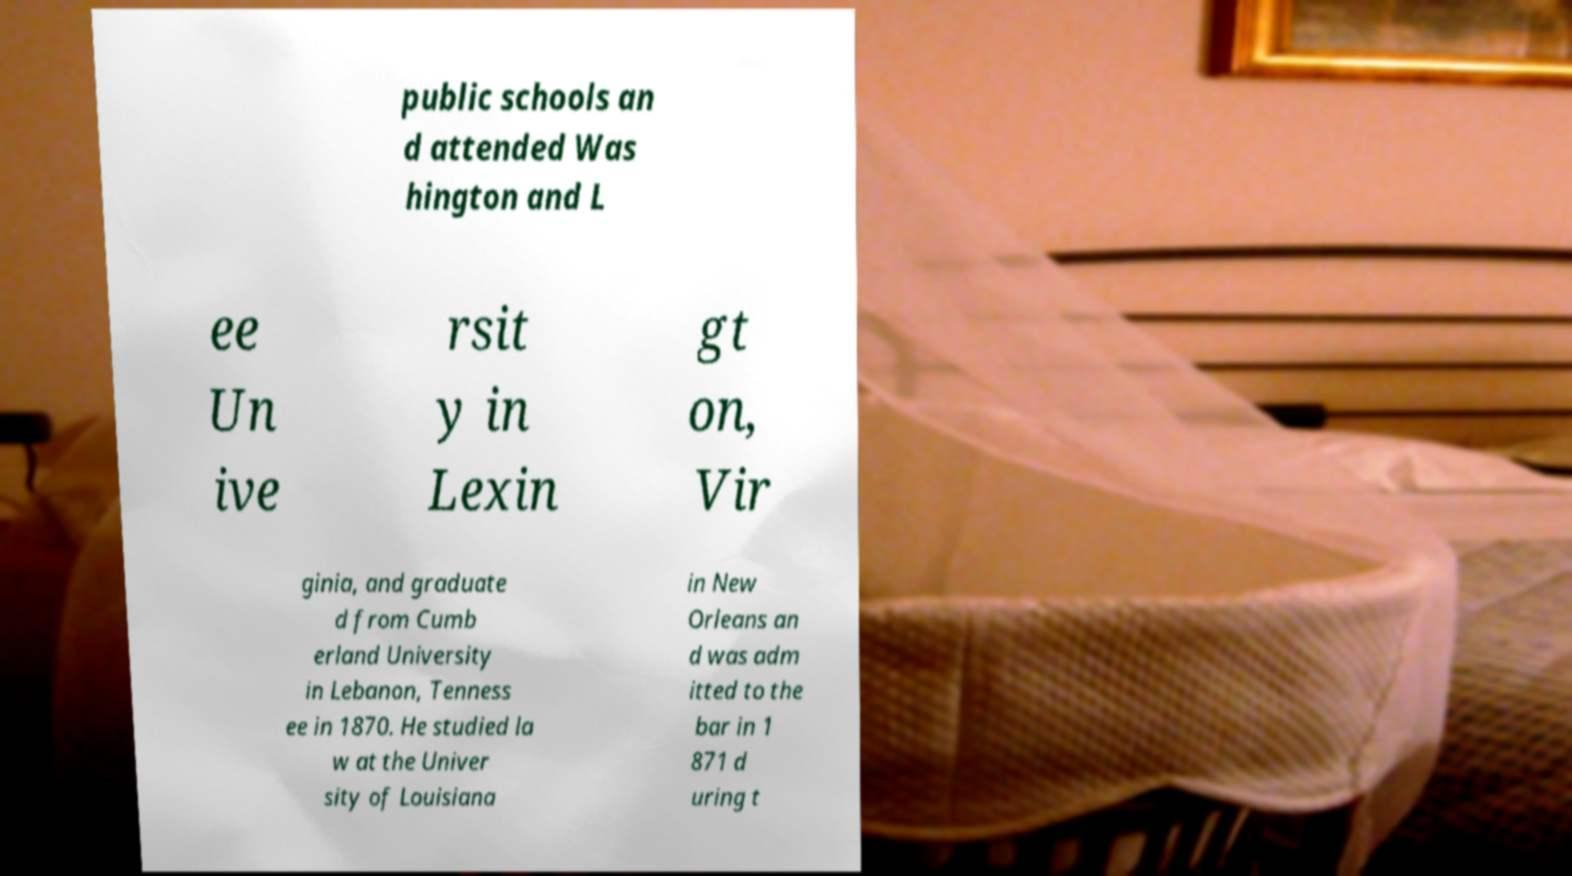Could you assist in decoding the text presented in this image and type it out clearly? public schools an d attended Was hington and L ee Un ive rsit y in Lexin gt on, Vir ginia, and graduate d from Cumb erland University in Lebanon, Tenness ee in 1870. He studied la w at the Univer sity of Louisiana in New Orleans an d was adm itted to the bar in 1 871 d uring t 